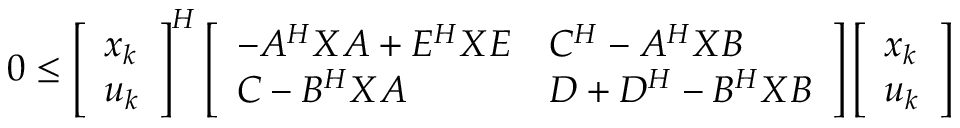Convert formula to latex. <formula><loc_0><loc_0><loc_500><loc_500>\begin{array} { r } { 0 \leq \left [ \begin{array} { l } { x _ { k } } \\ { u _ { k } } \end{array} \right ] ^ { H } \left [ \begin{array} { l l } { - A ^ { H } X A + E ^ { H } X E } & { C ^ { H } - A ^ { H } X B } \\ { C - B ^ { H } X A } & { D + D ^ { H } - B ^ { H } X B } \end{array} \right ] \left [ \begin{array} { l } { x _ { k } } \\ { u _ { k } } \end{array} \right ] } \end{array}</formula> 